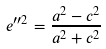Convert formula to latex. <formula><loc_0><loc_0><loc_500><loc_500>e ^ { \prime \prime 2 } = \frac { a ^ { 2 } - c ^ { 2 } } { a ^ { 2 } + c ^ { 2 } }</formula> 